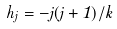Convert formula to latex. <formula><loc_0><loc_0><loc_500><loc_500>h _ { j } = - j ( j + 1 ) / k</formula> 